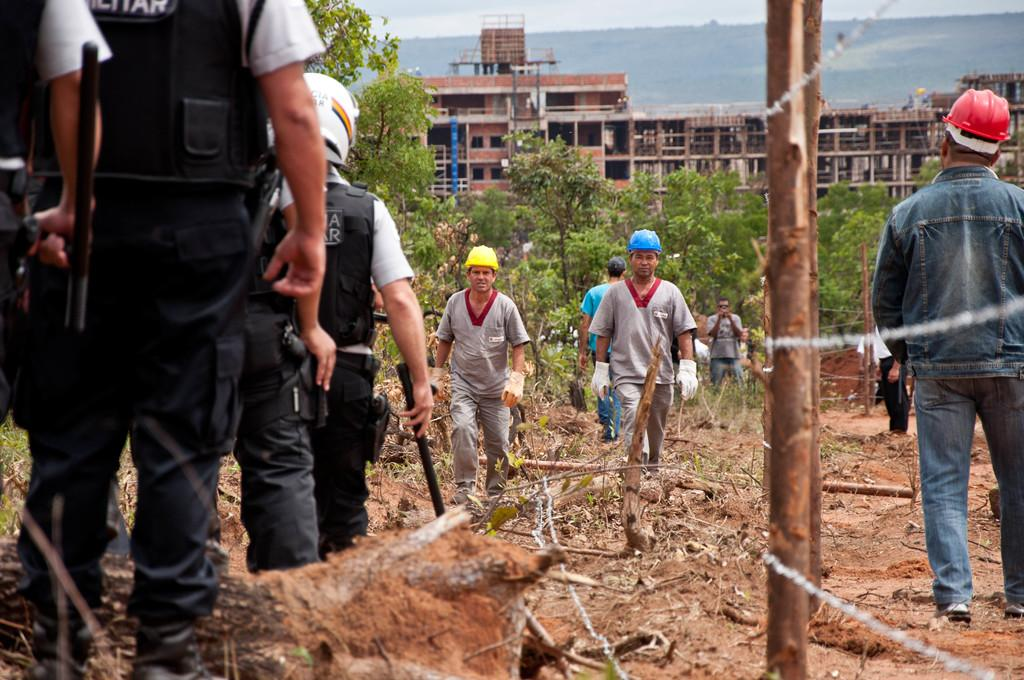What is happening on the ground in the image? There are people on the ground in the image. What are some of the people doing in the image? Some of the people are holding objects. What type of structures can be seen in the image? There are buildings in the image. What other natural elements are present in the image? There are trees and mountains in the image. What part of the natural environment is visible in the image? The sky is visible in the image. What type of cord is being used to tie the celery in the image? There is no celery or cord present in the image. What type of iron is visible in the image? There is no iron present in the image. 